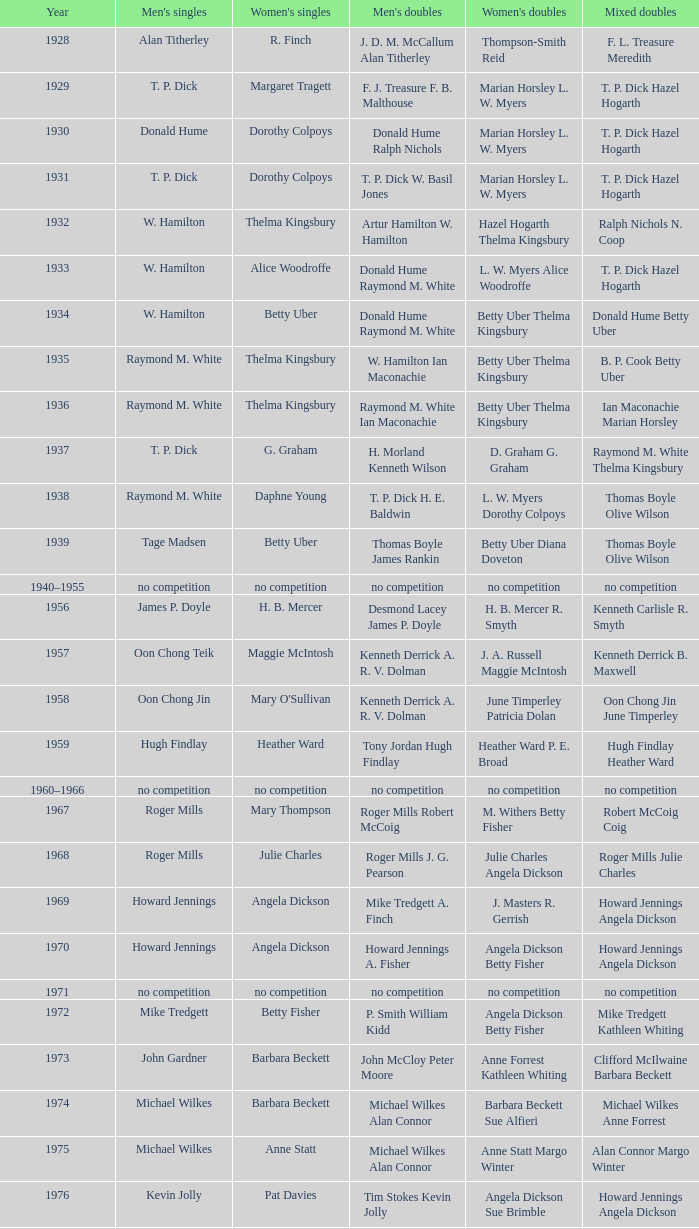Who won the Women's doubles in the year that David Eddy Eddy Sutton won the Men's doubles, and that David Eddy won the Men's singles? Anne Statt Jane Webster. Help me parse the entirety of this table. {'header': ['Year', "Men's singles", "Women's singles", "Men's doubles", "Women's doubles", 'Mixed doubles'], 'rows': [['1928', 'Alan Titherley', 'R. Finch', 'J. D. M. McCallum Alan Titherley', 'Thompson-Smith Reid', 'F. L. Treasure Meredith'], ['1929', 'T. P. Dick', 'Margaret Tragett', 'F. J. Treasure F. B. Malthouse', 'Marian Horsley L. W. Myers', 'T. P. Dick Hazel Hogarth'], ['1930', 'Donald Hume', 'Dorothy Colpoys', 'Donald Hume Ralph Nichols', 'Marian Horsley L. W. Myers', 'T. P. Dick Hazel Hogarth'], ['1931', 'T. P. Dick', 'Dorothy Colpoys', 'T. P. Dick W. Basil Jones', 'Marian Horsley L. W. Myers', 'T. P. Dick Hazel Hogarth'], ['1932', 'W. Hamilton', 'Thelma Kingsbury', 'Artur Hamilton W. Hamilton', 'Hazel Hogarth Thelma Kingsbury', 'Ralph Nichols N. Coop'], ['1933', 'W. Hamilton', 'Alice Woodroffe', 'Donald Hume Raymond M. White', 'L. W. Myers Alice Woodroffe', 'T. P. Dick Hazel Hogarth'], ['1934', 'W. Hamilton', 'Betty Uber', 'Donald Hume Raymond M. White', 'Betty Uber Thelma Kingsbury', 'Donald Hume Betty Uber'], ['1935', 'Raymond M. White', 'Thelma Kingsbury', 'W. Hamilton Ian Maconachie', 'Betty Uber Thelma Kingsbury', 'B. P. Cook Betty Uber'], ['1936', 'Raymond M. White', 'Thelma Kingsbury', 'Raymond M. White Ian Maconachie', 'Betty Uber Thelma Kingsbury', 'Ian Maconachie Marian Horsley'], ['1937', 'T. P. Dick', 'G. Graham', 'H. Morland Kenneth Wilson', 'D. Graham G. Graham', 'Raymond M. White Thelma Kingsbury'], ['1938', 'Raymond M. White', 'Daphne Young', 'T. P. Dick H. E. Baldwin', 'L. W. Myers Dorothy Colpoys', 'Thomas Boyle Olive Wilson'], ['1939', 'Tage Madsen', 'Betty Uber', 'Thomas Boyle James Rankin', 'Betty Uber Diana Doveton', 'Thomas Boyle Olive Wilson'], ['1940–1955', 'no competition', 'no competition', 'no competition', 'no competition', 'no competition'], ['1956', 'James P. Doyle', 'H. B. Mercer', 'Desmond Lacey James P. Doyle', 'H. B. Mercer R. Smyth', 'Kenneth Carlisle R. Smyth'], ['1957', 'Oon Chong Teik', 'Maggie McIntosh', 'Kenneth Derrick A. R. V. Dolman', 'J. A. Russell Maggie McIntosh', 'Kenneth Derrick B. Maxwell'], ['1958', 'Oon Chong Jin', "Mary O'Sullivan", 'Kenneth Derrick A. R. V. Dolman', 'June Timperley Patricia Dolan', 'Oon Chong Jin June Timperley'], ['1959', 'Hugh Findlay', 'Heather Ward', 'Tony Jordan Hugh Findlay', 'Heather Ward P. E. Broad', 'Hugh Findlay Heather Ward'], ['1960–1966', 'no competition', 'no competition', 'no competition', 'no competition', 'no competition'], ['1967', 'Roger Mills', 'Mary Thompson', 'Roger Mills Robert McCoig', 'M. Withers Betty Fisher', 'Robert McCoig Coig'], ['1968', 'Roger Mills', 'Julie Charles', 'Roger Mills J. G. Pearson', 'Julie Charles Angela Dickson', 'Roger Mills Julie Charles'], ['1969', 'Howard Jennings', 'Angela Dickson', 'Mike Tredgett A. Finch', 'J. Masters R. Gerrish', 'Howard Jennings Angela Dickson'], ['1970', 'Howard Jennings', 'Angela Dickson', 'Howard Jennings A. Fisher', 'Angela Dickson Betty Fisher', 'Howard Jennings Angela Dickson'], ['1971', 'no competition', 'no competition', 'no competition', 'no competition', 'no competition'], ['1972', 'Mike Tredgett', 'Betty Fisher', 'P. Smith William Kidd', 'Angela Dickson Betty Fisher', 'Mike Tredgett Kathleen Whiting'], ['1973', 'John Gardner', 'Barbara Beckett', 'John McCloy Peter Moore', 'Anne Forrest Kathleen Whiting', 'Clifford McIlwaine Barbara Beckett'], ['1974', 'Michael Wilkes', 'Barbara Beckett', 'Michael Wilkes Alan Connor', 'Barbara Beckett Sue Alfieri', 'Michael Wilkes Anne Forrest'], ['1975', 'Michael Wilkes', 'Anne Statt', 'Michael Wilkes Alan Connor', 'Anne Statt Margo Winter', 'Alan Connor Margo Winter'], ['1976', 'Kevin Jolly', 'Pat Davies', 'Tim Stokes Kevin Jolly', 'Angela Dickson Sue Brimble', 'Howard Jennings Angela Dickson'], ['1977', 'David Eddy', 'Paula Kilvington', 'David Eddy Eddy Sutton', 'Anne Statt Jane Webster', 'David Eddy Barbara Giles'], ['1978', 'Mike Tredgett', 'Gillian Gilks', 'David Eddy Eddy Sutton', 'Barbara Sutton Marjan Ridder', 'Elliot Stuart Gillian Gilks'], ['1979', 'Kevin Jolly', 'Nora Perry', 'Ray Stevens Mike Tredgett', 'Barbara Sutton Nora Perry', 'Mike Tredgett Nora Perry'], ['1980', 'Thomas Kihlström', 'Jane Webster', 'Thomas Kihlström Bengt Fröman', 'Jane Webster Karen Puttick', 'Billy Gilliland Karen Puttick'], ['1981', 'Ray Stevens', 'Gillian Gilks', 'Ray Stevens Mike Tredgett', 'Gillian Gilks Paula Kilvington', 'Mike Tredgett Nora Perry'], ['1982', 'Steve Baddeley', 'Karen Bridge', 'David Eddy Eddy Sutton', 'Karen Chapman Sally Podger', 'Billy Gilliland Karen Chapman'], ['1983', 'Steve Butler', 'Sally Podger', 'Mike Tredgett Dipak Tailor', 'Nora Perry Jane Webster', 'Dipak Tailor Nora Perry'], ['1984', 'Steve Butler', 'Karen Beckman', 'Mike Tredgett Martin Dew', 'Helen Troke Karen Chapman', 'Mike Tredgett Karen Chapman'], ['1985', 'Morten Frost', 'Charlotte Hattens', 'Billy Gilliland Dan Travers', 'Gillian Gilks Helen Troke', 'Martin Dew Gillian Gilks'], ['1986', 'Darren Hall', 'Fiona Elliott', 'Martin Dew Dipak Tailor', 'Karen Beckman Sara Halsall', 'Jesper Knudsen Nettie Nielsen'], ['1987', 'Darren Hall', 'Fiona Elliott', 'Martin Dew Darren Hall', 'Karen Beckman Sara Halsall', 'Martin Dew Gillian Gilks'], ['1988', 'Vimal Kumar', 'Lee Jung-mi', 'Richard Outterside Mike Brown', 'Fiona Elliott Sara Halsall', 'Martin Dew Gillian Gilks'], ['1989', 'Darren Hall', 'Bang Soo-hyun', 'Nick Ponting Dave Wright', 'Karen Beckman Sara Sankey', 'Mike Brown Jillian Wallwork'], ['1990', 'Mathew Smith', 'Joanne Muggeridge', 'Nick Ponting Dave Wright', 'Karen Chapman Sara Sankey', 'Dave Wright Claire Palmer'], ['1991', 'Vimal Kumar', 'Denyse Julien', 'Nick Ponting Dave Wright', 'Cheryl Johnson Julie Bradbury', 'Nick Ponting Joanne Wright'], ['1992', 'Wei Yan', 'Fiona Smith', 'Michael Adams Chris Rees', 'Denyse Julien Doris Piché', 'Andy Goode Joanne Wright'], ['1993', 'Anders Nielsen', 'Sue Louis Lane', 'Nick Ponting Dave Wright', 'Julie Bradbury Sara Sankey', 'Nick Ponting Joanne Wright'], ['1994', 'Darren Hall', 'Marina Andrievskaya', 'Michael Adams Simon Archer', 'Julie Bradbury Joanne Wright', 'Chris Hunt Joanne Wright'], ['1995', 'Peter Rasmussen', 'Denyse Julien', 'Andrei Andropov Nikolai Zuyev', 'Julie Bradbury Joanne Wright', 'Nick Ponting Joanne Wright'], ['1996', 'Colin Haughton', 'Elena Rybkina', 'Andrei Andropov Nikolai Zuyev', 'Elena Rybkina Marina Yakusheva', 'Nikolai Zuyev Marina Yakusheva'], ['1997', 'Chris Bruil', 'Kelly Morgan', 'Ian Pearson James Anderson', 'Nicole van Hooren Brenda Conijn', 'Quinten van Dalm Nicole van Hooren'], ['1998', 'Dicky Palyama', 'Brenda Beenhakker', 'James Anderson Ian Sullivan', 'Sara Sankey Ella Tripp', 'James Anderson Sara Sankey'], ['1999', 'Daniel Eriksson', 'Marina Andrievskaya', 'Joachim Tesche Jean-Philippe Goyette', 'Marina Andrievskaya Catrine Bengtsson', 'Henrik Andersson Marina Andrievskaya'], ['2000', 'Richard Vaughan', 'Marina Yakusheva', 'Joachim Andersson Peter Axelsson', 'Irina Ruslyakova Marina Yakusheva', 'Peter Jeffrey Joanne Davies'], ['2001', 'Irwansyah', 'Brenda Beenhakker', 'Vincent Laigle Svetoslav Stoyanov', 'Sara Sankey Ella Tripp', 'Nikolai Zuyev Marina Yakusheva'], ['2002', 'Irwansyah', 'Karina de Wit', 'Nikolai Zuyev Stanislav Pukhov', 'Ella Tripp Joanne Wright', 'Nikolai Zuyev Marina Yakusheva'], ['2003', 'Irwansyah', 'Ella Karachkova', 'Ashley Thilthorpe Kristian Roebuck', 'Ella Karachkova Anastasia Russkikh', 'Alexandr Russkikh Anastasia Russkikh'], ['2004', 'Nathan Rice', 'Petya Nedelcheva', 'Reuben Gordown Aji Basuki Sindoro', 'Petya Nedelcheva Yuan Wemyss', 'Matthew Hughes Kelly Morgan'], ['2005', 'Chetan Anand', 'Eleanor Cox', 'Andrew Ellis Dean George', 'Hayley Connor Heather Olver', 'Valiyaveetil Diju Jwala Gutta'], ['2006', 'Irwansyah', 'Huang Chia-chi', 'Matthew Hughes Martyn Lewis', 'Natalie Munt Mariana Agathangelou', 'Kristian Roebuck Natalie Munt'], ['2007', 'Marc Zwiebler', 'Jill Pittard', 'Wojciech Szkudlarczyk Adam Cwalina', 'Chloe Magee Bing Huang', 'Wojciech Szkudlarczyk Malgorzata Kurdelska'], ['2008', 'Brice Leverdez', 'Kati Tolmoff', 'Andrew Bowman Martyn Lewis', 'Mariana Agathangelou Jillie Cooper', 'Watson Briggs Jillie Cooper'], ['2009', 'Kristian Nielsen', 'Tatjana Bibik', 'Vitaliy Durkin Alexandr Nikolaenko', 'Valeria Sorokina Nina Vislova', 'Vitaliy Durkin Nina Vislova'], ['2010', 'Pablo Abián', 'Anita Raj Kaur', 'Peter Käsbauer Josche Zurwonne', 'Joanne Quay Swee Ling Anita Raj Kaur', 'Peter Käsbauer Johanna Goliszewski'], ['2011', 'Niluka Karunaratne', 'Nicole Schaller', 'Chris Coles Matthew Nottingham', 'Ng Hui Ern Ng Hui Lin', 'Martin Campbell Ng Hui Lin'], ['2012', 'Chou Tien-chen', 'Chiang Mei-hui', 'Marcus Ellis Paul Van Rietvelde', 'Gabrielle White Lauren Smith', 'Marcus Ellis Gabrielle White']]} 